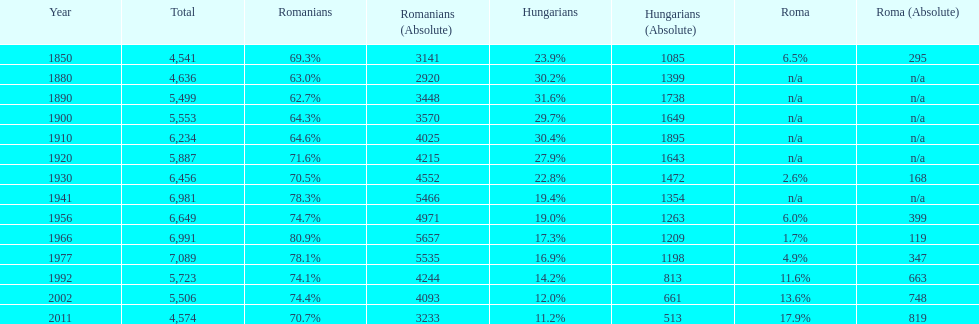What percent of the population were romanians according to the last year on this chart? 70.7%. 